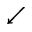Convert formula to latex. <formula><loc_0><loc_0><loc_500><loc_500>\swarrow</formula> 